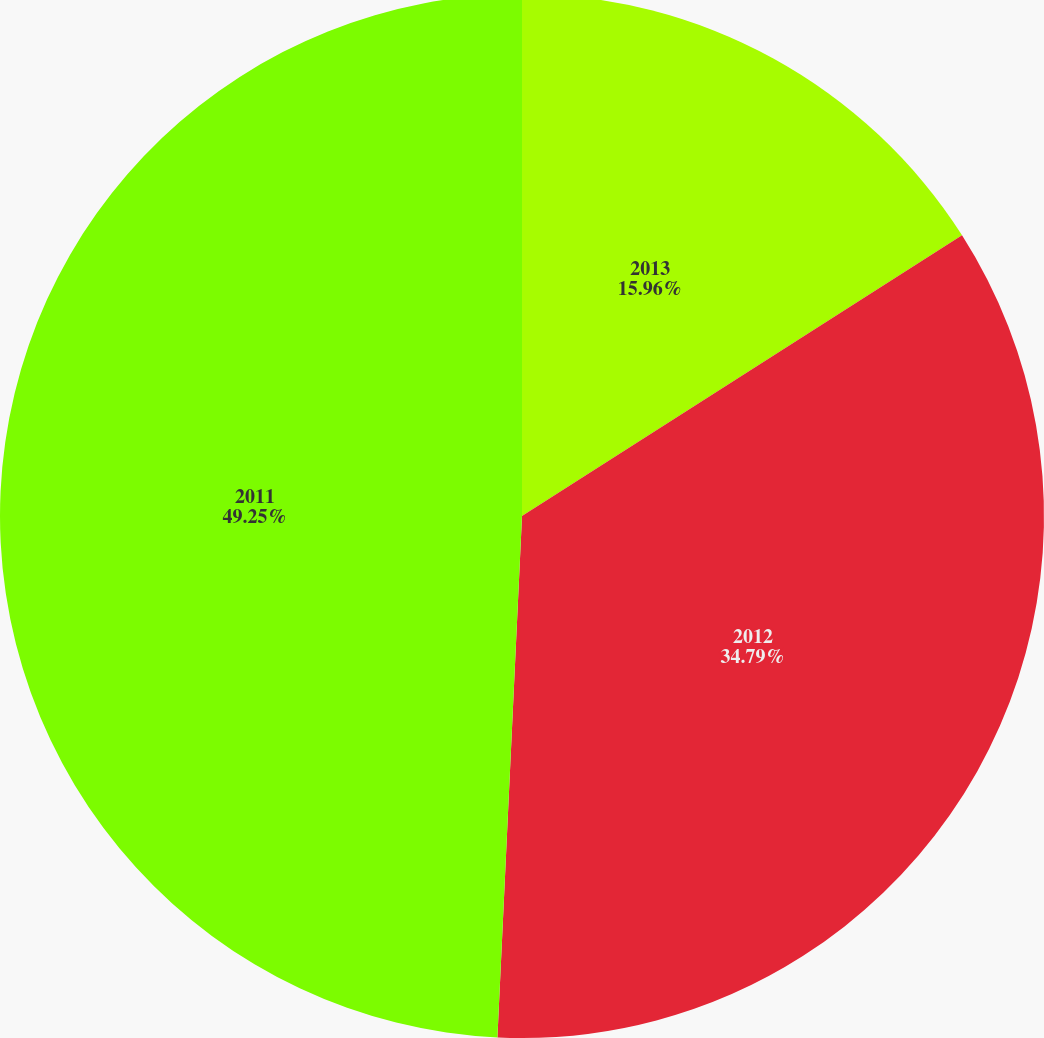Convert chart. <chart><loc_0><loc_0><loc_500><loc_500><pie_chart><fcel>2013<fcel>2012<fcel>2011<nl><fcel>15.96%<fcel>34.79%<fcel>49.25%<nl></chart> 